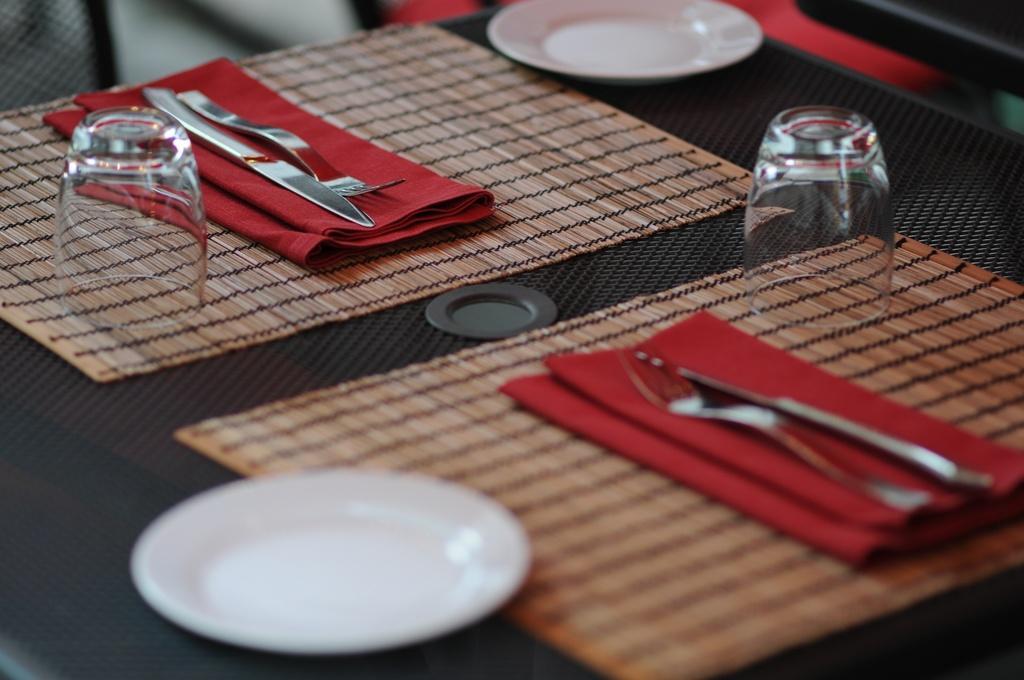Describe this image in one or two sentences. There is a white color saucer on the table. On which, there are glasses, knives and forks on the red color clothes which are arranged on other cloths and there is another white color saucer. 